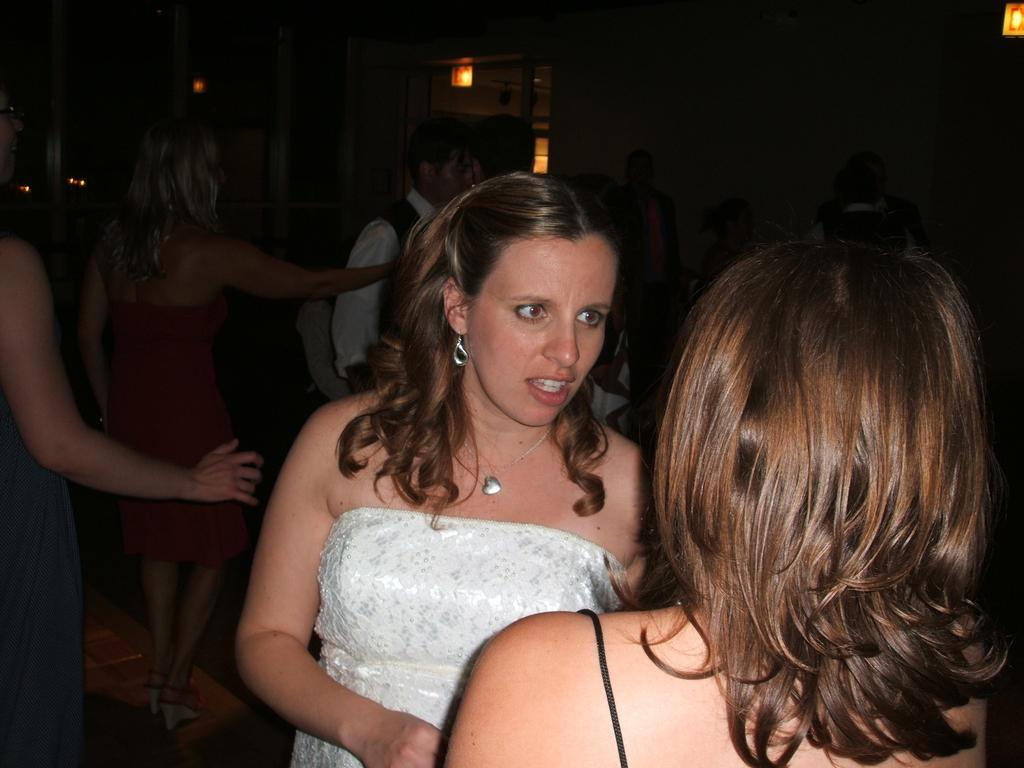What is happening in the image? There are people standing in the image. What can be seen in the background or surroundings? There are lights visible in the image. What type of cake is being served in the image? There is no cake present in the image; it only shows people standing and lights. Is there any milk visible in the image? There is no milk visible in the image. 